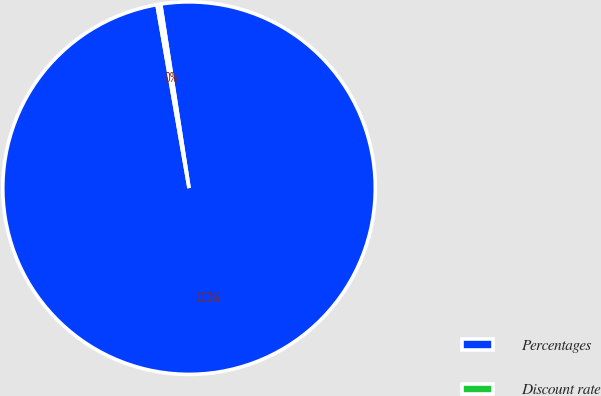Convert chart. <chart><loc_0><loc_0><loc_500><loc_500><pie_chart><fcel>Percentages<fcel>Discount rate<nl><fcel>99.68%<fcel>0.32%<nl></chart> 